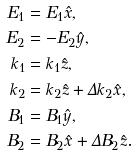Convert formula to latex. <formula><loc_0><loc_0><loc_500><loc_500>E _ { 1 } & = E _ { 1 } \hat { x } , \\ E _ { 2 } & = - E _ { 2 } \hat { y } , \\ k _ { 1 } & = k _ { 1 } \hat { z } , \\ k _ { 2 } & = k _ { 2 } \hat { z } + \Delta k _ { 2 } \hat { x } , \\ B _ { 1 } & = B _ { 1 } \hat { y } , \\ B _ { 2 } & = B _ { 2 } \hat { x } + \Delta B _ { 2 } \hat { z } .</formula> 